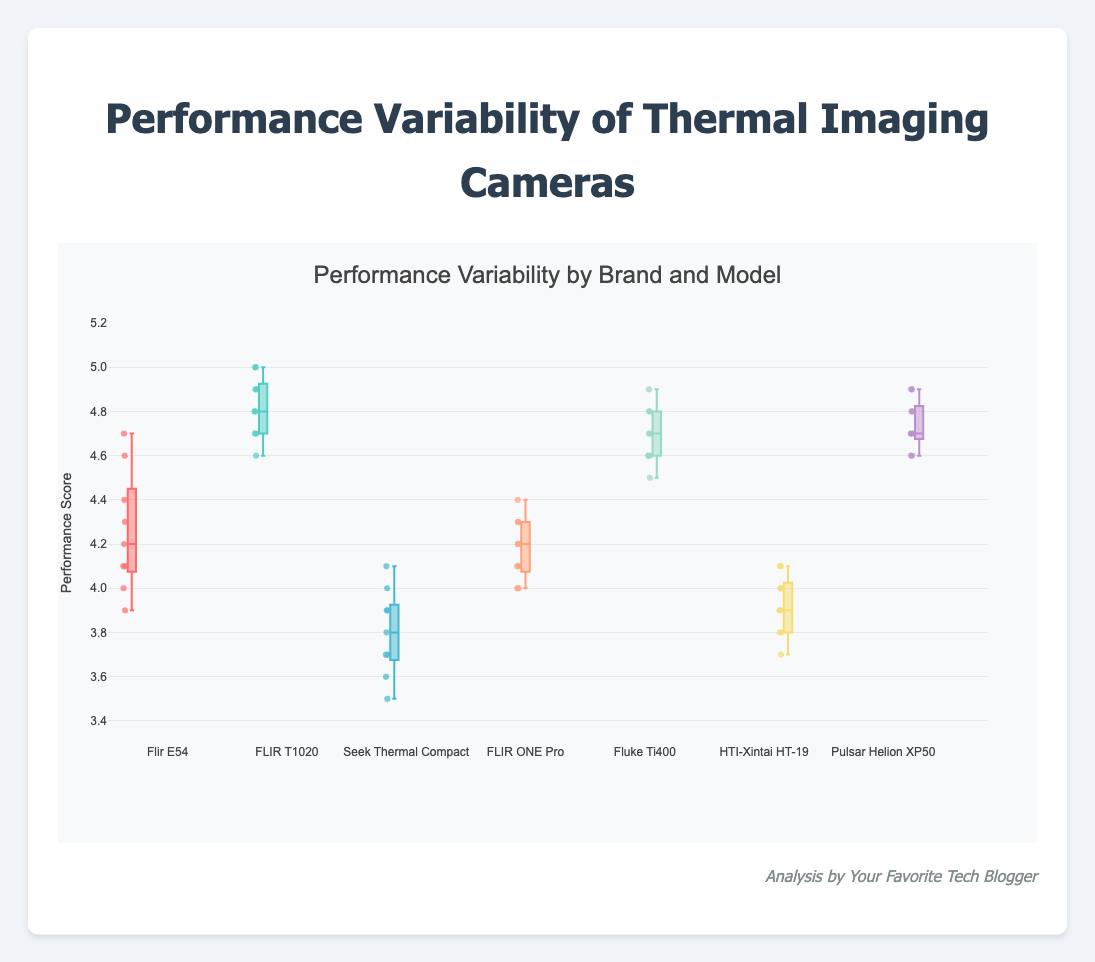What is the title of the plot? The title is located at the top of the plot, displaying a brief description of the chart's content.
Answer: Performance Variability by Brand and Model Which camera model has the highest median performance score? In box plots, the median is indicated by the central line within each box. By comparing the median lines among all models, FLIR T1020 has the highest median.
Answer: FLIR T1020 What is the range of the y-axis? The range of the y-axis can be found by observing the numeric labels at both the bottom and top ends of the axis.
Answer: 3.3 to 5.2 Which camera brand shows the least variability in performance scores? Variability in a box plot is shown by the spread of the box and whiskers. The FLIR T1020 has the least variability, as its whiskers and interquartile range are narrow.
Answer: FLIR T1020 What is the main color of the box for the "Seek Thermal Compact"? The box's color can be identified by finding the relevant legend or directly observing the plot.
Answer: Blue-Green Which cameras have outliers? Outliers in box plots are marked as points outside the whiskers. By inspecting the plot, no camera models have visible outliers.
Answer: None How does the median performance score of "HTI-Xintai HT-19" compare to that of "FLIR ONE Pro"? The median of "HTI-Xintai HT-19" is found by looking at its central box line, and it is lower compared to the median of "FLIR ONE Pro."
Answer: Lower Which model has the highest maximum performance score? The highest value in a box plot is indicated by the top whisker or the uppermost data point. FLIR T1020 has the highest max performance score.
Answer: FLIR T1020 Considering "Flir E54" and "Fluke Ti400," which one shows greater variability? Variability is seen through the length of the box and whiskers. The "Flir E54" has a greater spread than "Fluke Ti400," implying higher variability.
Answer: Flir E54 What is the interquartile range (IQR) of the "Pulsar Helion XP50"? The IQR is the length of the box, representing the middle 50% of the data. This length can be visually compared to the y-axis increments. The "Pulsar Helion XP50" has an IQR of about 4.7 to 4.8.
Answer: 0.1 